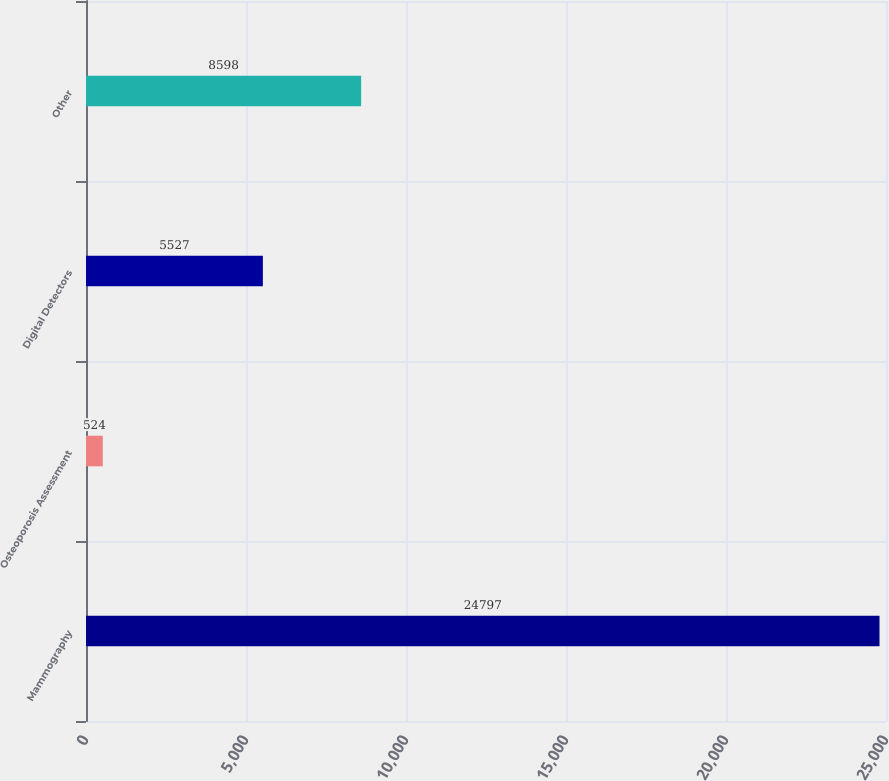<chart> <loc_0><loc_0><loc_500><loc_500><bar_chart><fcel>Mammography<fcel>Osteoporosis Assessment<fcel>Digital Detectors<fcel>Other<nl><fcel>24797<fcel>524<fcel>5527<fcel>8598<nl></chart> 